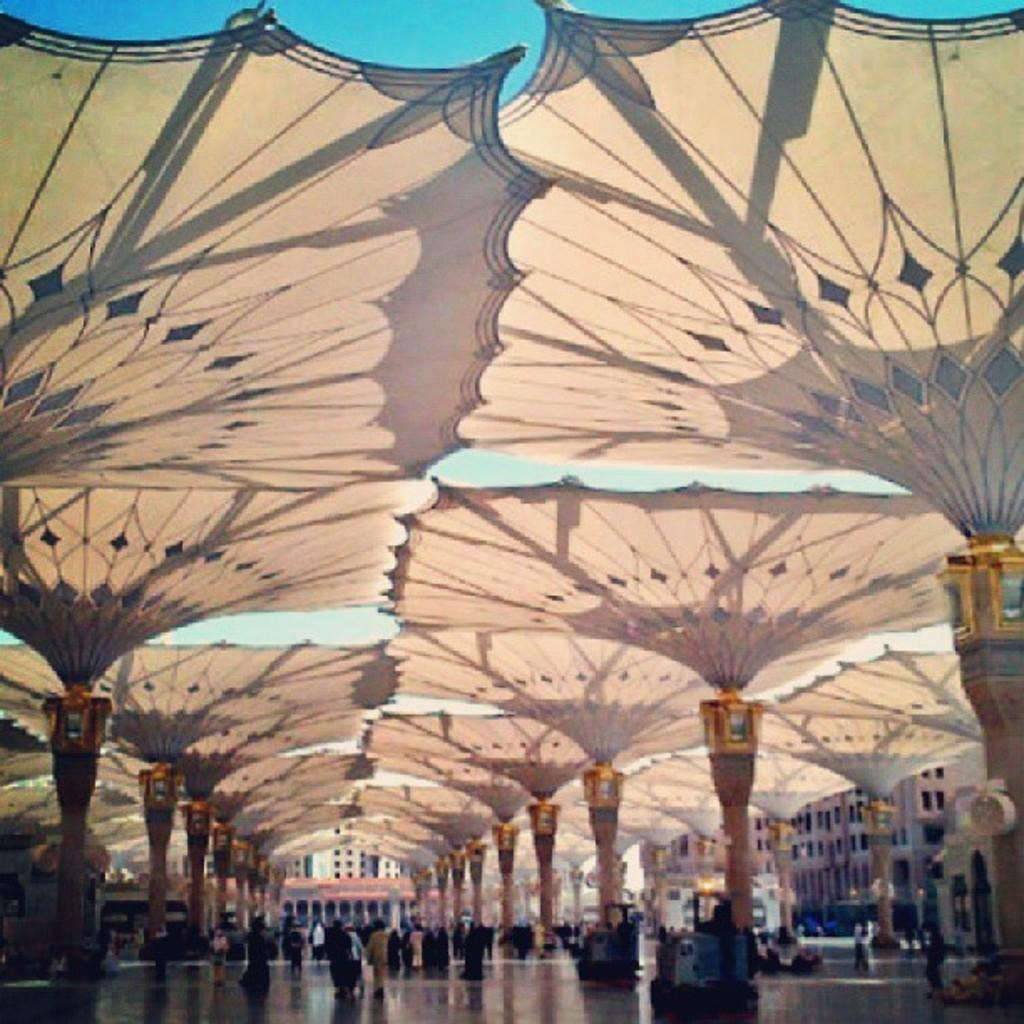What is happening in the image? There is a group of people standing in the image. What can be seen in the background of the image? There are buildings visible in the image. What is visible above the buildings and people? The sky is visible in the image. What is the purpose of the field in the image? There is no field present in the image; it features a group of people standing and buildings in the background. 